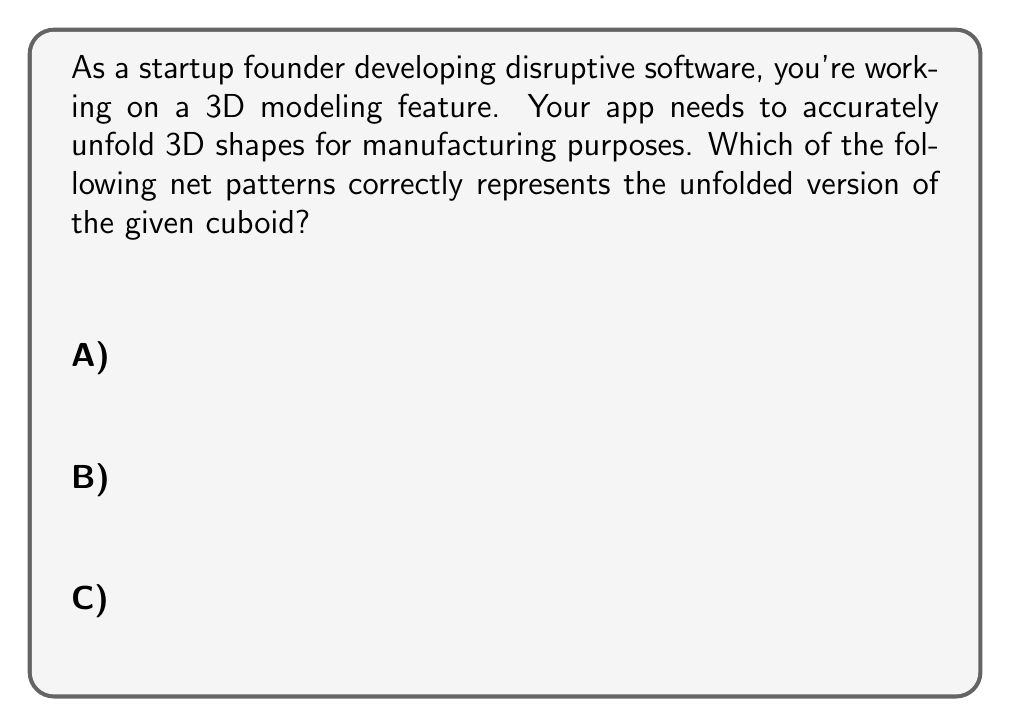Can you solve this math problem? To solve this problem, let's analyze the given cuboid and its dimensions:

1) The cuboid has dimensions $2 \times 1 \times 1$.

2) To create a net, we need to unfold all faces of the cuboid:
   - 2 faces of size $2 \times 1$ (front and back)
   - 2 faces of size $2 \times 1$ (top and bottom)
   - 2 faces of size $1 \times 1$ (left and right)

3) Let's examine each option:

   A) This net has the correct number of faces, but the arrangement is incorrect. It has two $2 \times 1$ faces in the middle, which wouldn't fold into a cuboid properly.

   B) This net has 6 faces, but the dimensions are incorrect. It has five $1 \times 1$ faces and one $2 \times 1$ face, which doesn't match our cuboid.

   C) This net correctly represents our cuboid:
      - It has two $2 \times 1$ faces (top and bottom of the net)
      - It has two $2 \times 1$ faces (middle sections of the net)
      - It has two $1 \times 1$ faces (leftmost and rightmost sections)

4) We can mentally fold option C to form the given cuboid:
   - The top and bottom $2 \times 1$ sections form the front and back
   - The middle $2 \times 1$ sections form the top and bottom
   - The $1 \times 1$ sections on the sides form the left and right faces

Therefore, option C is the correct unfolded pattern for the given cuboid.
Answer: C 